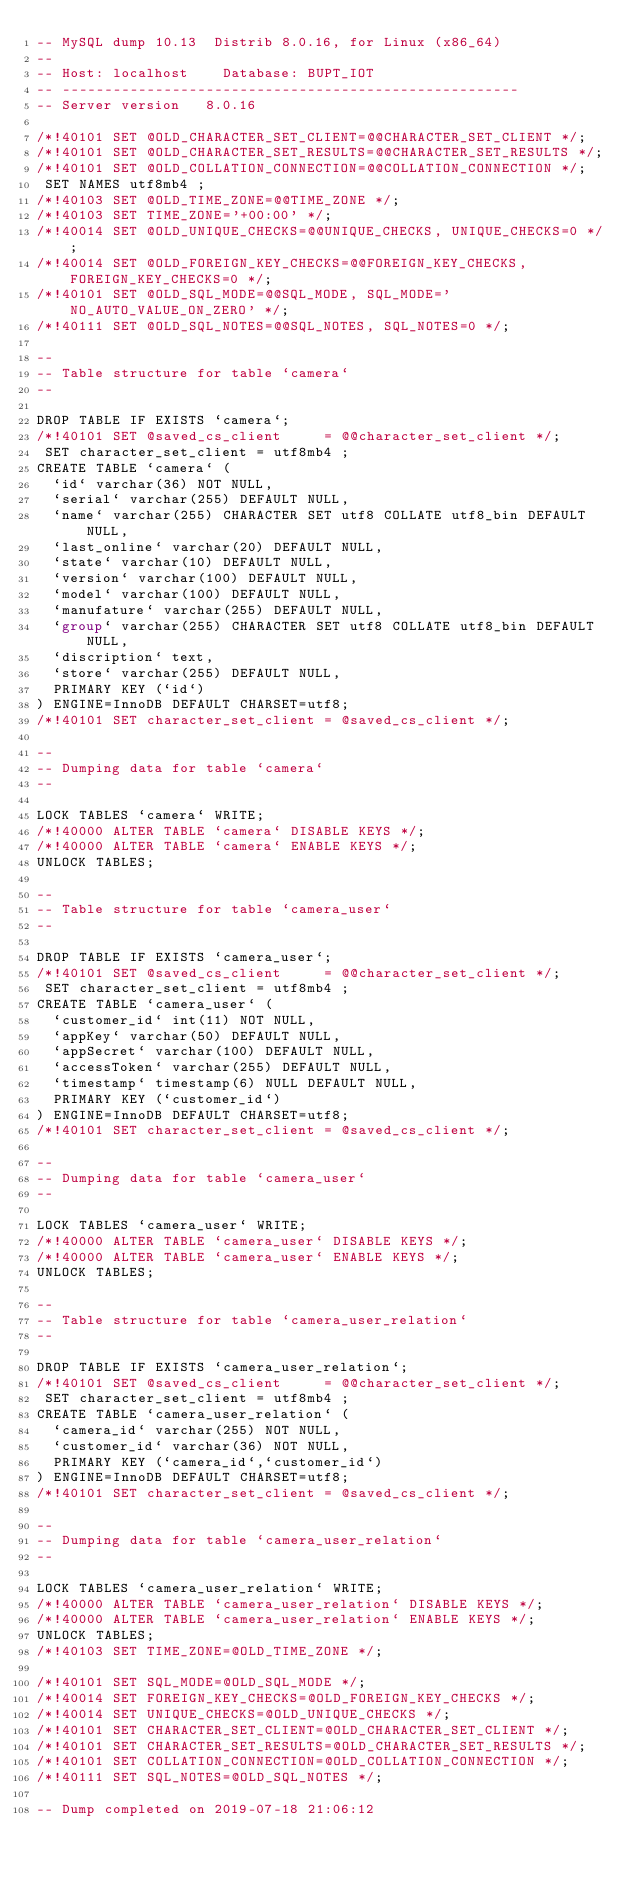<code> <loc_0><loc_0><loc_500><loc_500><_SQL_>-- MySQL dump 10.13  Distrib 8.0.16, for Linux (x86_64)
--
-- Host: localhost    Database: BUPT_IOT
-- ------------------------------------------------------
-- Server version	8.0.16

/*!40101 SET @OLD_CHARACTER_SET_CLIENT=@@CHARACTER_SET_CLIENT */;
/*!40101 SET @OLD_CHARACTER_SET_RESULTS=@@CHARACTER_SET_RESULTS */;
/*!40101 SET @OLD_COLLATION_CONNECTION=@@COLLATION_CONNECTION */;
 SET NAMES utf8mb4 ;
/*!40103 SET @OLD_TIME_ZONE=@@TIME_ZONE */;
/*!40103 SET TIME_ZONE='+00:00' */;
/*!40014 SET @OLD_UNIQUE_CHECKS=@@UNIQUE_CHECKS, UNIQUE_CHECKS=0 */;
/*!40014 SET @OLD_FOREIGN_KEY_CHECKS=@@FOREIGN_KEY_CHECKS, FOREIGN_KEY_CHECKS=0 */;
/*!40101 SET @OLD_SQL_MODE=@@SQL_MODE, SQL_MODE='NO_AUTO_VALUE_ON_ZERO' */;
/*!40111 SET @OLD_SQL_NOTES=@@SQL_NOTES, SQL_NOTES=0 */;

--
-- Table structure for table `camera`
--

DROP TABLE IF EXISTS `camera`;
/*!40101 SET @saved_cs_client     = @@character_set_client */;
 SET character_set_client = utf8mb4 ;
CREATE TABLE `camera` (
  `id` varchar(36) NOT NULL,
  `serial` varchar(255) DEFAULT NULL,
  `name` varchar(255) CHARACTER SET utf8 COLLATE utf8_bin DEFAULT NULL,
  `last_online` varchar(20) DEFAULT NULL,
  `state` varchar(10) DEFAULT NULL,
  `version` varchar(100) DEFAULT NULL,
  `model` varchar(100) DEFAULT NULL,
  `manufature` varchar(255) DEFAULT NULL,
  `group` varchar(255) CHARACTER SET utf8 COLLATE utf8_bin DEFAULT NULL,
  `discription` text,
  `store` varchar(255) DEFAULT NULL,
  PRIMARY KEY (`id`)
) ENGINE=InnoDB DEFAULT CHARSET=utf8;
/*!40101 SET character_set_client = @saved_cs_client */;

--
-- Dumping data for table `camera`
--

LOCK TABLES `camera` WRITE;
/*!40000 ALTER TABLE `camera` DISABLE KEYS */;
/*!40000 ALTER TABLE `camera` ENABLE KEYS */;
UNLOCK TABLES;

--
-- Table structure for table `camera_user`
--

DROP TABLE IF EXISTS `camera_user`;
/*!40101 SET @saved_cs_client     = @@character_set_client */;
 SET character_set_client = utf8mb4 ;
CREATE TABLE `camera_user` (
  `customer_id` int(11) NOT NULL,
  `appKey` varchar(50) DEFAULT NULL,
  `appSecret` varchar(100) DEFAULT NULL,
  `accessToken` varchar(255) DEFAULT NULL,
  `timestamp` timestamp(6) NULL DEFAULT NULL,
  PRIMARY KEY (`customer_id`)
) ENGINE=InnoDB DEFAULT CHARSET=utf8;
/*!40101 SET character_set_client = @saved_cs_client */;

--
-- Dumping data for table `camera_user`
--

LOCK TABLES `camera_user` WRITE;
/*!40000 ALTER TABLE `camera_user` DISABLE KEYS */;
/*!40000 ALTER TABLE `camera_user` ENABLE KEYS */;
UNLOCK TABLES;

--
-- Table structure for table `camera_user_relation`
--

DROP TABLE IF EXISTS `camera_user_relation`;
/*!40101 SET @saved_cs_client     = @@character_set_client */;
 SET character_set_client = utf8mb4 ;
CREATE TABLE `camera_user_relation` (
  `camera_id` varchar(255) NOT NULL,
  `customer_id` varchar(36) NOT NULL,
  PRIMARY KEY (`camera_id`,`customer_id`)
) ENGINE=InnoDB DEFAULT CHARSET=utf8;
/*!40101 SET character_set_client = @saved_cs_client */;

--
-- Dumping data for table `camera_user_relation`
--

LOCK TABLES `camera_user_relation` WRITE;
/*!40000 ALTER TABLE `camera_user_relation` DISABLE KEYS */;
/*!40000 ALTER TABLE `camera_user_relation` ENABLE KEYS */;
UNLOCK TABLES;
/*!40103 SET TIME_ZONE=@OLD_TIME_ZONE */;

/*!40101 SET SQL_MODE=@OLD_SQL_MODE */;
/*!40014 SET FOREIGN_KEY_CHECKS=@OLD_FOREIGN_KEY_CHECKS */;
/*!40014 SET UNIQUE_CHECKS=@OLD_UNIQUE_CHECKS */;
/*!40101 SET CHARACTER_SET_CLIENT=@OLD_CHARACTER_SET_CLIENT */;
/*!40101 SET CHARACTER_SET_RESULTS=@OLD_CHARACTER_SET_RESULTS */;
/*!40101 SET COLLATION_CONNECTION=@OLD_COLLATION_CONNECTION */;
/*!40111 SET SQL_NOTES=@OLD_SQL_NOTES */;

-- Dump completed on 2019-07-18 21:06:12
</code> 